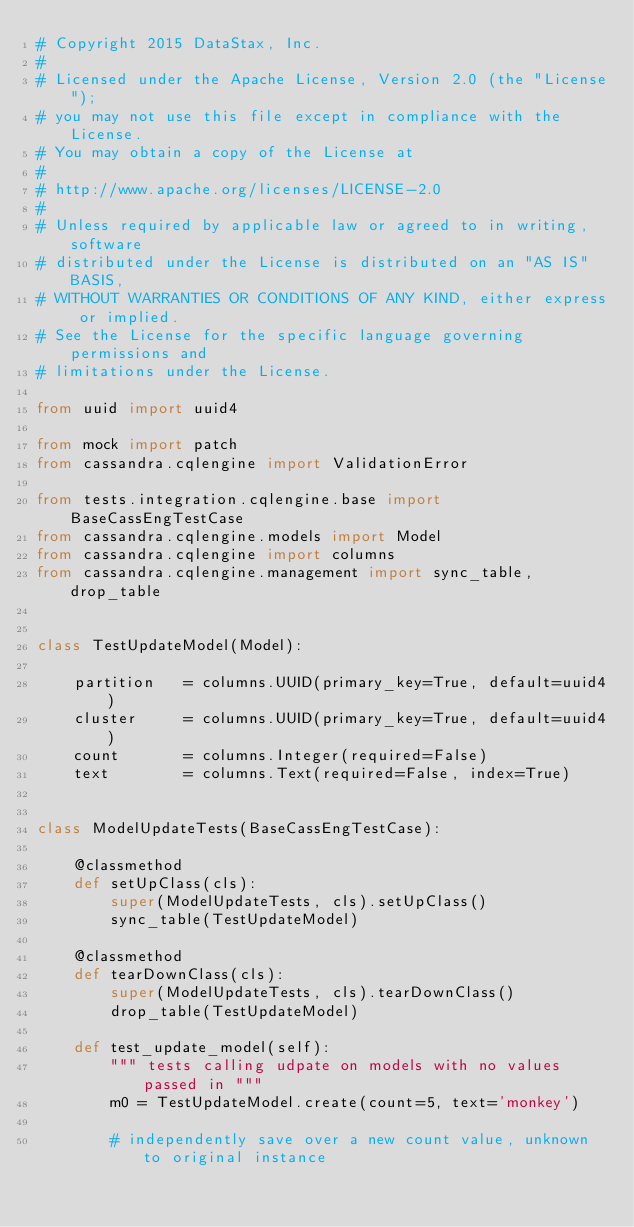Convert code to text. <code><loc_0><loc_0><loc_500><loc_500><_Python_># Copyright 2015 DataStax, Inc.
#
# Licensed under the Apache License, Version 2.0 (the "License");
# you may not use this file except in compliance with the License.
# You may obtain a copy of the License at
#
# http://www.apache.org/licenses/LICENSE-2.0
#
# Unless required by applicable law or agreed to in writing, software
# distributed under the License is distributed on an "AS IS" BASIS,
# WITHOUT WARRANTIES OR CONDITIONS OF ANY KIND, either express or implied.
# See the License for the specific language governing permissions and
# limitations under the License.

from uuid import uuid4

from mock import patch
from cassandra.cqlengine import ValidationError

from tests.integration.cqlengine.base import BaseCassEngTestCase
from cassandra.cqlengine.models import Model
from cassandra.cqlengine import columns
from cassandra.cqlengine.management import sync_table, drop_table


class TestUpdateModel(Model):

    partition   = columns.UUID(primary_key=True, default=uuid4)
    cluster     = columns.UUID(primary_key=True, default=uuid4)
    count       = columns.Integer(required=False)
    text        = columns.Text(required=False, index=True)


class ModelUpdateTests(BaseCassEngTestCase):

    @classmethod
    def setUpClass(cls):
        super(ModelUpdateTests, cls).setUpClass()
        sync_table(TestUpdateModel)

    @classmethod
    def tearDownClass(cls):
        super(ModelUpdateTests, cls).tearDownClass()
        drop_table(TestUpdateModel)

    def test_update_model(self):
        """ tests calling udpate on models with no values passed in """
        m0 = TestUpdateModel.create(count=5, text='monkey')

        # independently save over a new count value, unknown to original instance</code> 